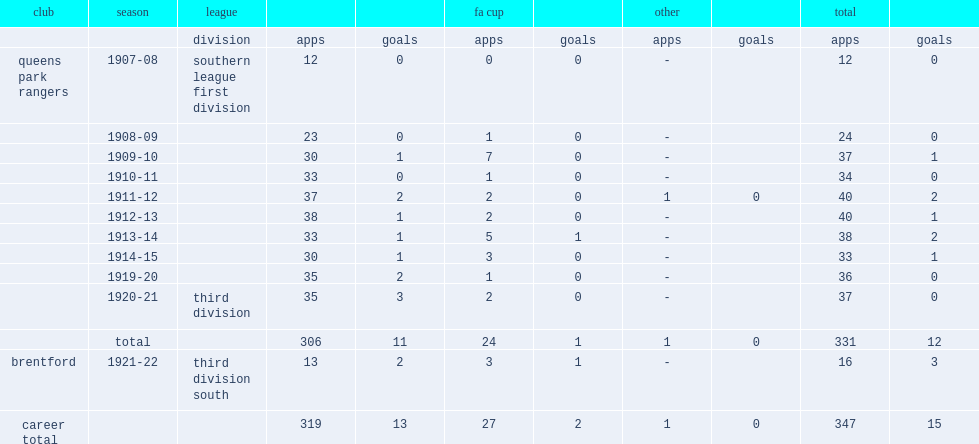Which club did archie mitchell play for in 1920-21? Queens park rangers. 